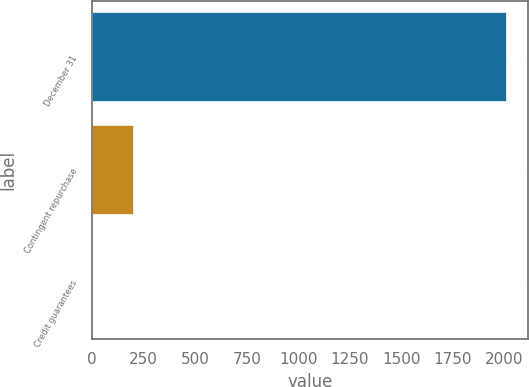<chart> <loc_0><loc_0><loc_500><loc_500><bar_chart><fcel>December 31<fcel>Contingent repurchase<fcel>Credit guarantees<nl><fcel>2016<fcel>203.4<fcel>2<nl></chart> 